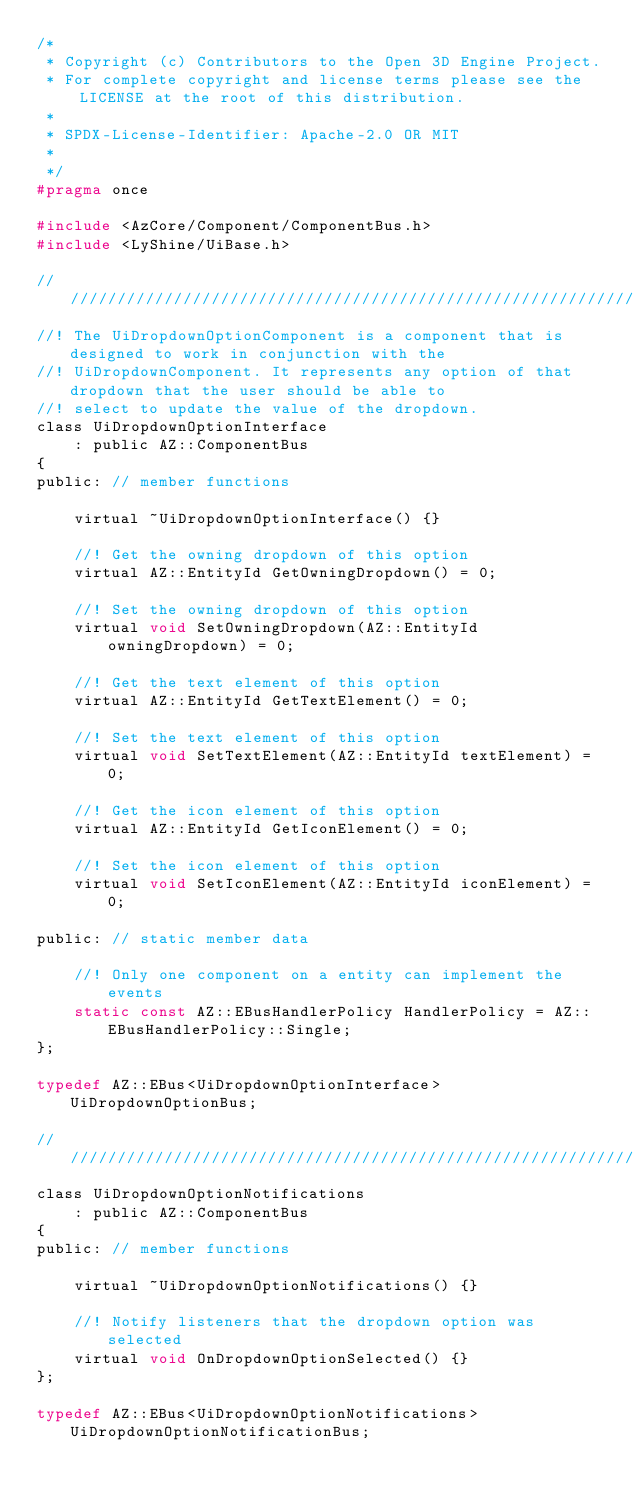Convert code to text. <code><loc_0><loc_0><loc_500><loc_500><_C_>/*
 * Copyright (c) Contributors to the Open 3D Engine Project.
 * For complete copyright and license terms please see the LICENSE at the root of this distribution.
 *
 * SPDX-License-Identifier: Apache-2.0 OR MIT
 *
 */
#pragma once

#include <AzCore/Component/ComponentBus.h>
#include <LyShine/UiBase.h>

////////////////////////////////////////////////////////////////////////////////////////////////////
//! The UiDropdownOptionComponent is a component that is designed to work in conjunction with the
//! UiDropdownComponent. It represents any option of that dropdown that the user should be able to
//! select to update the value of the dropdown.
class UiDropdownOptionInterface
    : public AZ::ComponentBus
{
public: // member functions

    virtual ~UiDropdownOptionInterface() {}

    //! Get the owning dropdown of this option
    virtual AZ::EntityId GetOwningDropdown() = 0;

    //! Set the owning dropdown of this option
    virtual void SetOwningDropdown(AZ::EntityId owningDropdown) = 0;

    //! Get the text element of this option
    virtual AZ::EntityId GetTextElement() = 0;

    //! Set the text element of this option
    virtual void SetTextElement(AZ::EntityId textElement) = 0;

    //! Get the icon element of this option
    virtual AZ::EntityId GetIconElement() = 0;

    //! Set the icon element of this option
    virtual void SetIconElement(AZ::EntityId iconElement) = 0;

public: // static member data

    //! Only one component on a entity can implement the events
    static const AZ::EBusHandlerPolicy HandlerPolicy = AZ::EBusHandlerPolicy::Single;
};

typedef AZ::EBus<UiDropdownOptionInterface> UiDropdownOptionBus;

////////////////////////////////////////////////////////////////////////////////////////////////////
class UiDropdownOptionNotifications
    : public AZ::ComponentBus
{
public: // member functions

    virtual ~UiDropdownOptionNotifications() {}

    //! Notify listeners that the dropdown option was selected
    virtual void OnDropdownOptionSelected() {}
};

typedef AZ::EBus<UiDropdownOptionNotifications> UiDropdownOptionNotificationBus;
</code> 